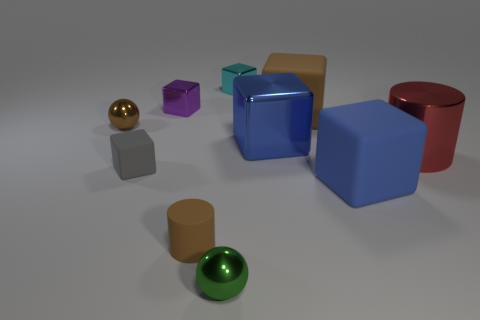Subtract all blue blocks. How many blocks are left? 4 Subtract all large blue cubes. How many cubes are left? 4 Subtract all red blocks. Subtract all gray cylinders. How many blocks are left? 6 Subtract all cylinders. How many objects are left? 8 Add 6 small spheres. How many small spheres exist? 8 Subtract 1 cyan cubes. How many objects are left? 9 Subtract all cyan metal things. Subtract all large yellow things. How many objects are left? 9 Add 7 tiny cyan metal cubes. How many tiny cyan metal cubes are left? 8 